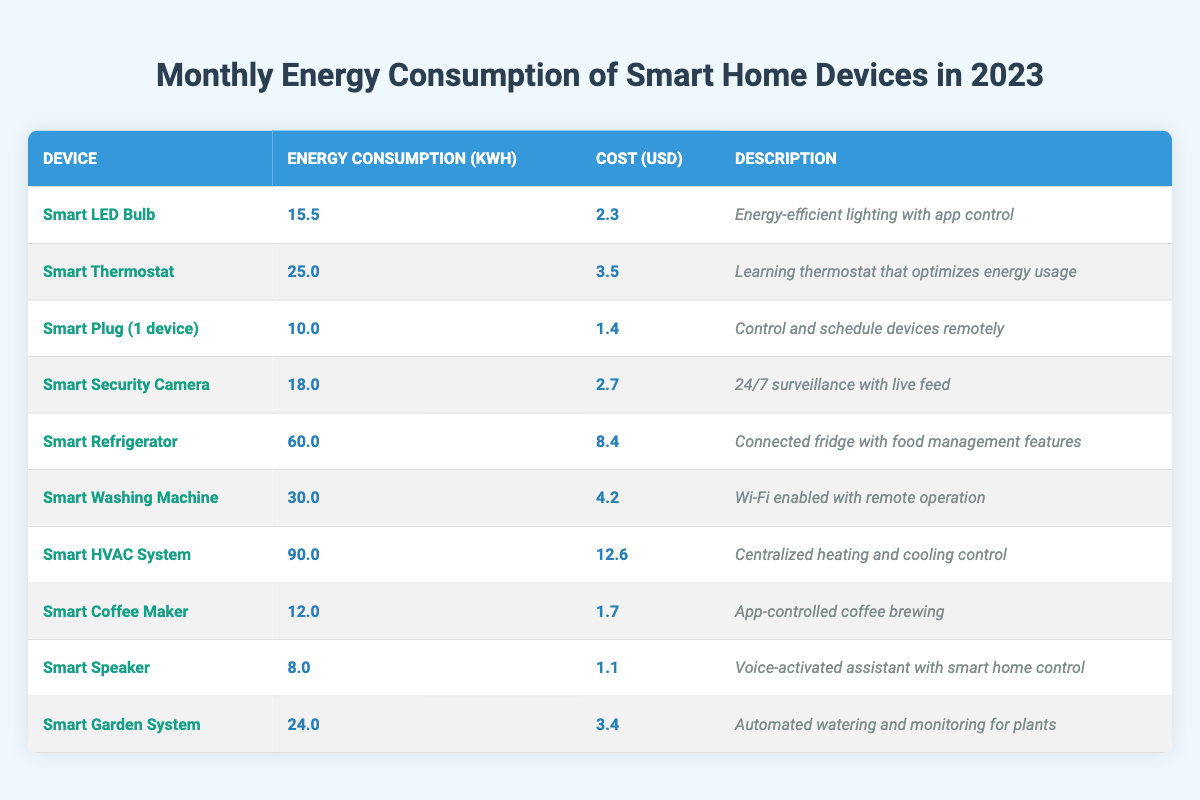What is the energy consumption of the Smart Refrigerator? The table lists the Smart Refrigerator under the "Device" column, showing an "Energy Consumption" value of **60.0 kWh**.
Answer: 60.0 kWh What is the total cost of using the Smart Washing Machine and the Smart Coffee Maker for a month? According to the table, the cost for the Smart Washing Machine is **4.2 USD** and for the Smart Coffee Maker is **1.7 USD**. Adding these gives **4.2 + 1.7 = 5.9 USD**.
Answer: 5.9 USD Which device has the lowest energy consumption? In the table, the Smart Speaker shows the lowest energy consumption at **8.0 kWh** compared to all other devices.
Answer: Smart Speaker Is the cost of running the Smart HVAC System higher than the Smart Thermostat? The Smart HVAC System costs **12.6 USD** while the Smart Thermostat costs **3.5 USD**. Since **12.6 is greater than 3.5**, the Smart HVAC System has a higher cost.
Answer: Yes What is the average energy consumption of all devices listed in the table? To find the average, we first sum the energy consumptions: **15.5 + 25.0 + 10.0 + 18.0 + 60.0 + 30.0 + 90.0 + 12.0 + 8.0 + 24.0 =  318.5 kWh**. There are 10 devices: **318.5 kWh / 10 = 31.85 kWh**.
Answer: 31.85 kWh Is it true that the Smart Security Camera consumes less energy than the Smart washing Machine? The Smart Security Camera consumes **18.0 kWh** while the Smart Washing Machine consumes **30.0 kWh**. Since **18.0 is less than 30.0**, the statement is true.
Answer: Yes What is the difference in energy consumption between the Smart HVAC System and the Smart LED Bulb? The Smart HVAC System consumes **90.0 kWh** and the Smart LED Bulb consumes **15.5 kWh**. The difference is **90.0 - 15.5 = 74.5 kWh**.
Answer: 74.5 kWh How much more does the Smart Refrigerator cost to run compared to the Smart Speaker? The Smart Refrigerator costs **8.4 USD** and the Smart Speaker costs **1.1 USD**, thus the difference is **8.4 - 1.1 = 7.3 USD**.
Answer: 7.3 USD Are there any devices that consume less than 15 kWh? Checking the table, the Smart Plug consumes **10.0 kWh** and the Smart Speaker consumes **8.0 kWh**, both less than 15 kWh.
Answer: Yes What percentage of the total monthly energy consumption is attributed to the Smart HVAC System? The total energy consumption is **318.5 kWh**. The HVAC System consumes **90.0 kWh**, so the percentage is calculated as **(90.0 / 318.5) * 100 ≈ 28.3%**.
Answer: 28.3% 